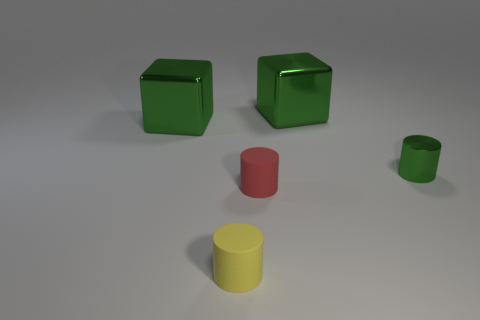Subtract all small matte cylinders. How many cylinders are left? 1 Add 3 green shiny blocks. How many objects exist? 8 Subtract all green cylinders. How many cylinders are left? 2 Subtract 1 blocks. How many blocks are left? 1 Add 4 green metallic blocks. How many green metallic blocks exist? 6 Subtract 0 brown cylinders. How many objects are left? 5 Subtract all cylinders. How many objects are left? 2 Subtract all purple cylinders. Subtract all red blocks. How many cylinders are left? 3 Subtract all cyan cubes. How many green cylinders are left? 1 Subtract all purple rubber blocks. Subtract all green metallic cylinders. How many objects are left? 4 